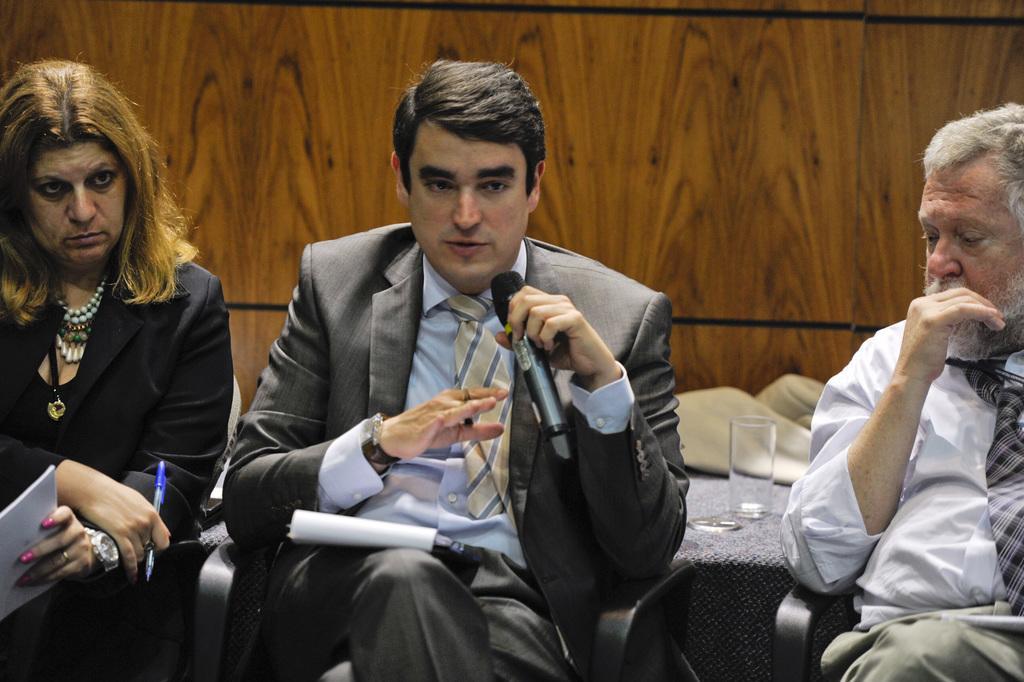Can you describe this image briefly? In this picture I can observe three members sitting on the chairs. Two of them are men and one of them is a woman. One of the man is holding a mic in his hand. In the background I can observe wall. 